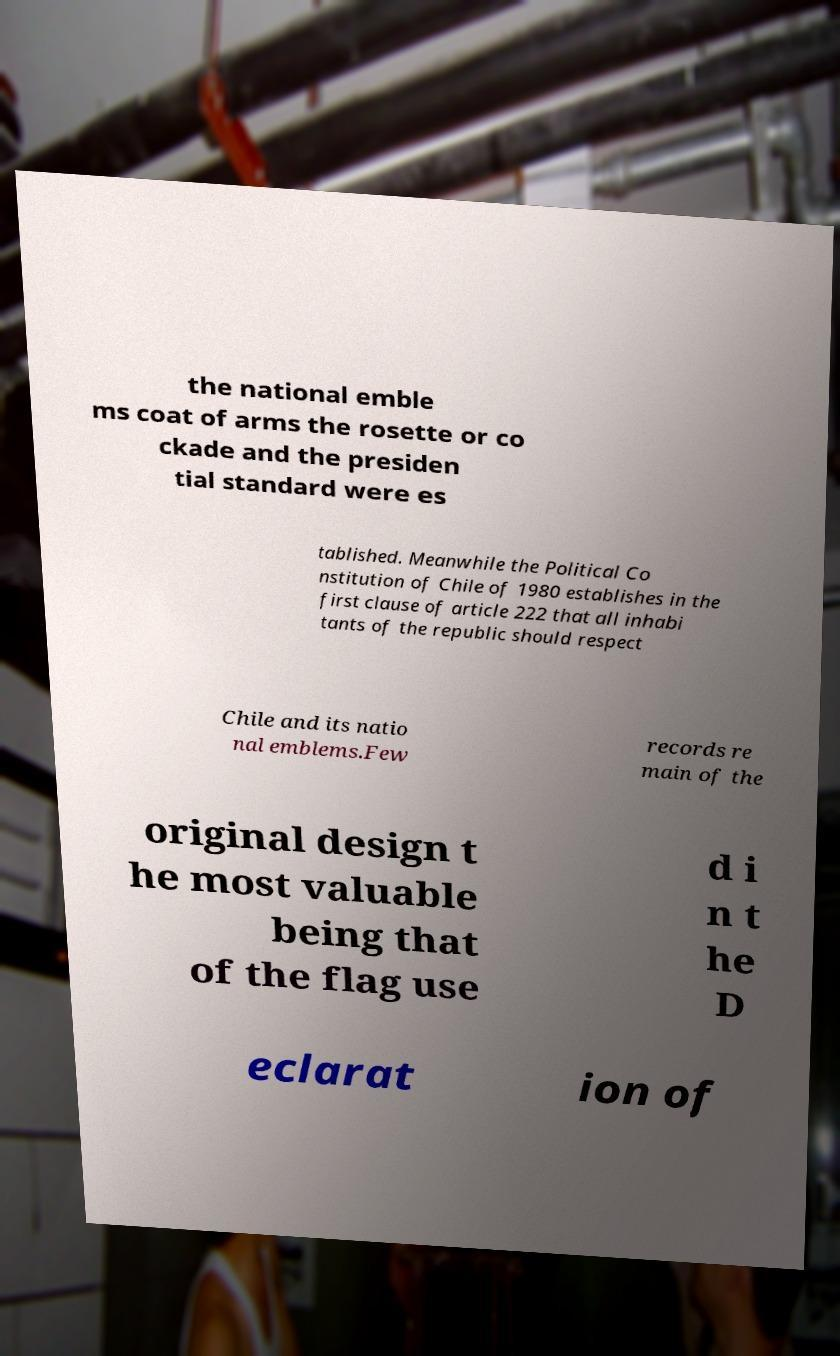Could you assist in decoding the text presented in this image and type it out clearly? the national emble ms coat of arms the rosette or co ckade and the presiden tial standard were es tablished. Meanwhile the Political Co nstitution of Chile of 1980 establishes in the first clause of article 222 that all inhabi tants of the republic should respect Chile and its natio nal emblems.Few records re main of the original design t he most valuable being that of the flag use d i n t he D eclarat ion of 